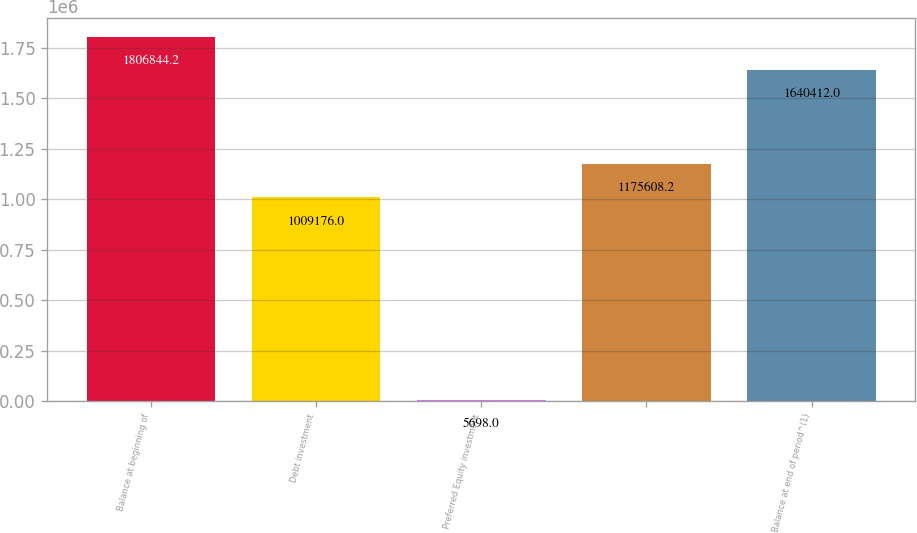Convert chart. <chart><loc_0><loc_0><loc_500><loc_500><bar_chart><fcel>Balance at beginning of<fcel>Debt investment<fcel>Preferred Equity investment<fcel>Unnamed: 3<fcel>Balance at end of period^(1)<nl><fcel>1.80684e+06<fcel>1.00918e+06<fcel>5698<fcel>1.17561e+06<fcel>1.64041e+06<nl></chart> 